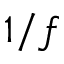<formula> <loc_0><loc_0><loc_500><loc_500>1 / f</formula> 